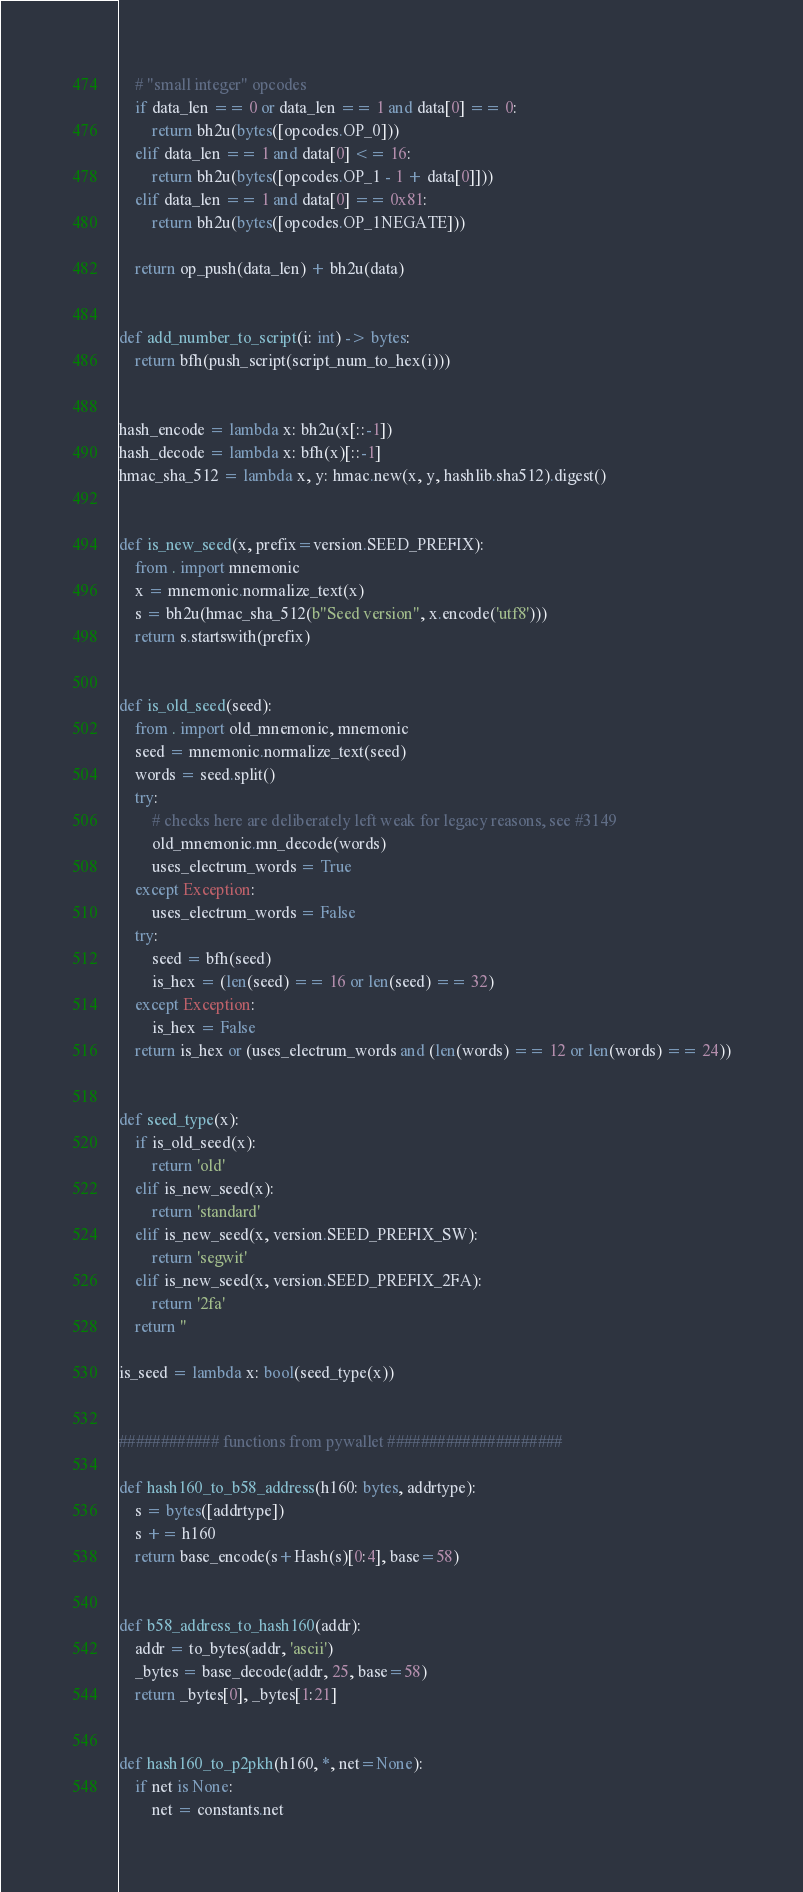Convert code to text. <code><loc_0><loc_0><loc_500><loc_500><_Python_>    # "small integer" opcodes
    if data_len == 0 or data_len == 1 and data[0] == 0:
        return bh2u(bytes([opcodes.OP_0]))
    elif data_len == 1 and data[0] <= 16:
        return bh2u(bytes([opcodes.OP_1 - 1 + data[0]]))
    elif data_len == 1 and data[0] == 0x81:
        return bh2u(bytes([opcodes.OP_1NEGATE]))

    return op_push(data_len) + bh2u(data)


def add_number_to_script(i: int) -> bytes:
    return bfh(push_script(script_num_to_hex(i)))


hash_encode = lambda x: bh2u(x[::-1])
hash_decode = lambda x: bfh(x)[::-1]
hmac_sha_512 = lambda x, y: hmac.new(x, y, hashlib.sha512).digest()


def is_new_seed(x, prefix=version.SEED_PREFIX):
    from . import mnemonic
    x = mnemonic.normalize_text(x)
    s = bh2u(hmac_sha_512(b"Seed version", x.encode('utf8')))
    return s.startswith(prefix)


def is_old_seed(seed):
    from . import old_mnemonic, mnemonic
    seed = mnemonic.normalize_text(seed)
    words = seed.split()
    try:
        # checks here are deliberately left weak for legacy reasons, see #3149
        old_mnemonic.mn_decode(words)
        uses_electrum_words = True
    except Exception:
        uses_electrum_words = False
    try:
        seed = bfh(seed)
        is_hex = (len(seed) == 16 or len(seed) == 32)
    except Exception:
        is_hex = False
    return is_hex or (uses_electrum_words and (len(words) == 12 or len(words) == 24))


def seed_type(x):
    if is_old_seed(x):
        return 'old'
    elif is_new_seed(x):
        return 'standard'
    elif is_new_seed(x, version.SEED_PREFIX_SW):
        return 'segwit'
    elif is_new_seed(x, version.SEED_PREFIX_2FA):
        return '2fa'
    return ''

is_seed = lambda x: bool(seed_type(x))


############ functions from pywallet #####################

def hash160_to_b58_address(h160: bytes, addrtype):
    s = bytes([addrtype])
    s += h160
    return base_encode(s+Hash(s)[0:4], base=58)


def b58_address_to_hash160(addr):
    addr = to_bytes(addr, 'ascii')
    _bytes = base_decode(addr, 25, base=58)
    return _bytes[0], _bytes[1:21]


def hash160_to_p2pkh(h160, *, net=None):
    if net is None:
        net = constants.net</code> 